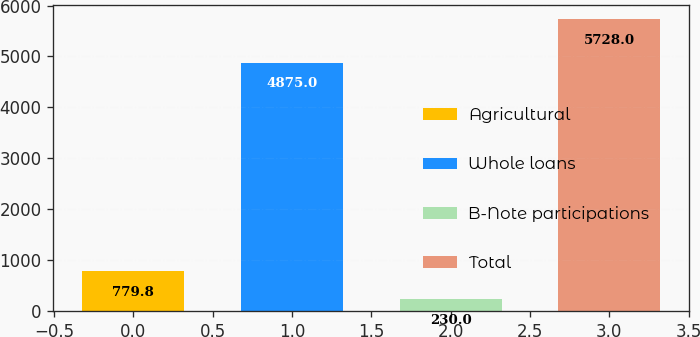Convert chart. <chart><loc_0><loc_0><loc_500><loc_500><bar_chart><fcel>Agricultural<fcel>Whole loans<fcel>B-Note participations<fcel>Total<nl><fcel>779.8<fcel>4875<fcel>230<fcel>5728<nl></chart> 